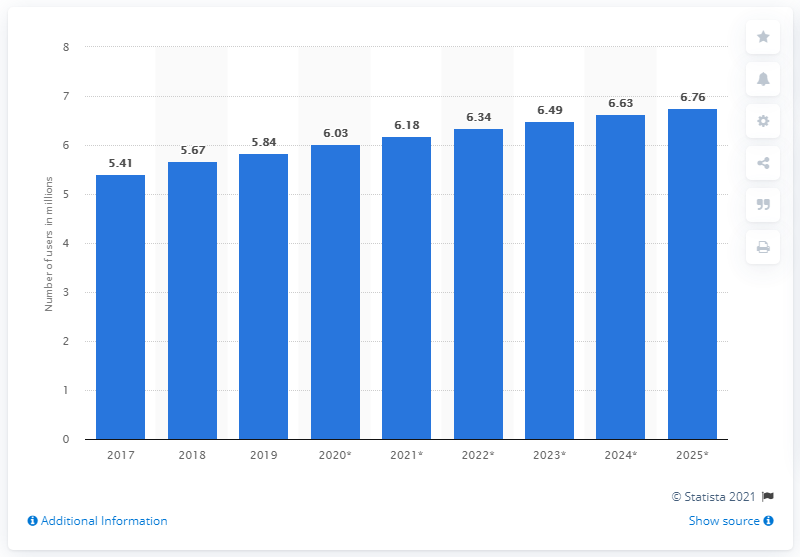Point out several critical features in this image. As of 2025, the number of Facebook users in Israel is projected to be approximately 6.76 million. In 2019, there were approximately 5.41 million Facebook users in Israel. 